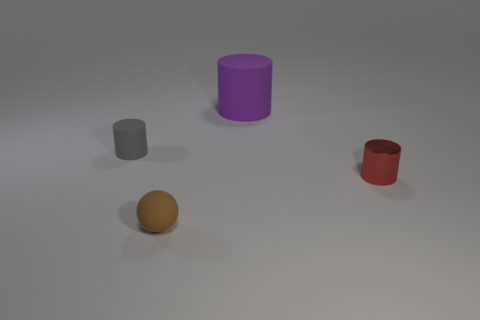Is there anything else that has the same shape as the brown matte object?
Make the answer very short. No. Is the color of the metallic cylinder the same as the ball?
Ensure brevity in your answer.  No. What number of large things are either purple rubber things or purple metal cylinders?
Your answer should be very brief. 1. Is there any other thing that is the same color as the metallic thing?
Make the answer very short. No. There is a small brown object that is the same material as the tiny gray cylinder; what is its shape?
Keep it short and to the point. Sphere. There is a matte thing that is in front of the tiny metallic object; how big is it?
Your answer should be very brief. Small. What is the shape of the tiny gray thing?
Your response must be concise. Cylinder. There is a rubber cylinder in front of the big cylinder; does it have the same size as the cylinder that is to the right of the large purple cylinder?
Offer a terse response. Yes. There is a matte cylinder that is behind the small cylinder that is on the left side of the matte cylinder that is behind the tiny gray cylinder; how big is it?
Provide a short and direct response. Large. There is a object right of the thing behind the matte cylinder that is on the left side of the large rubber thing; what is its shape?
Keep it short and to the point. Cylinder. 